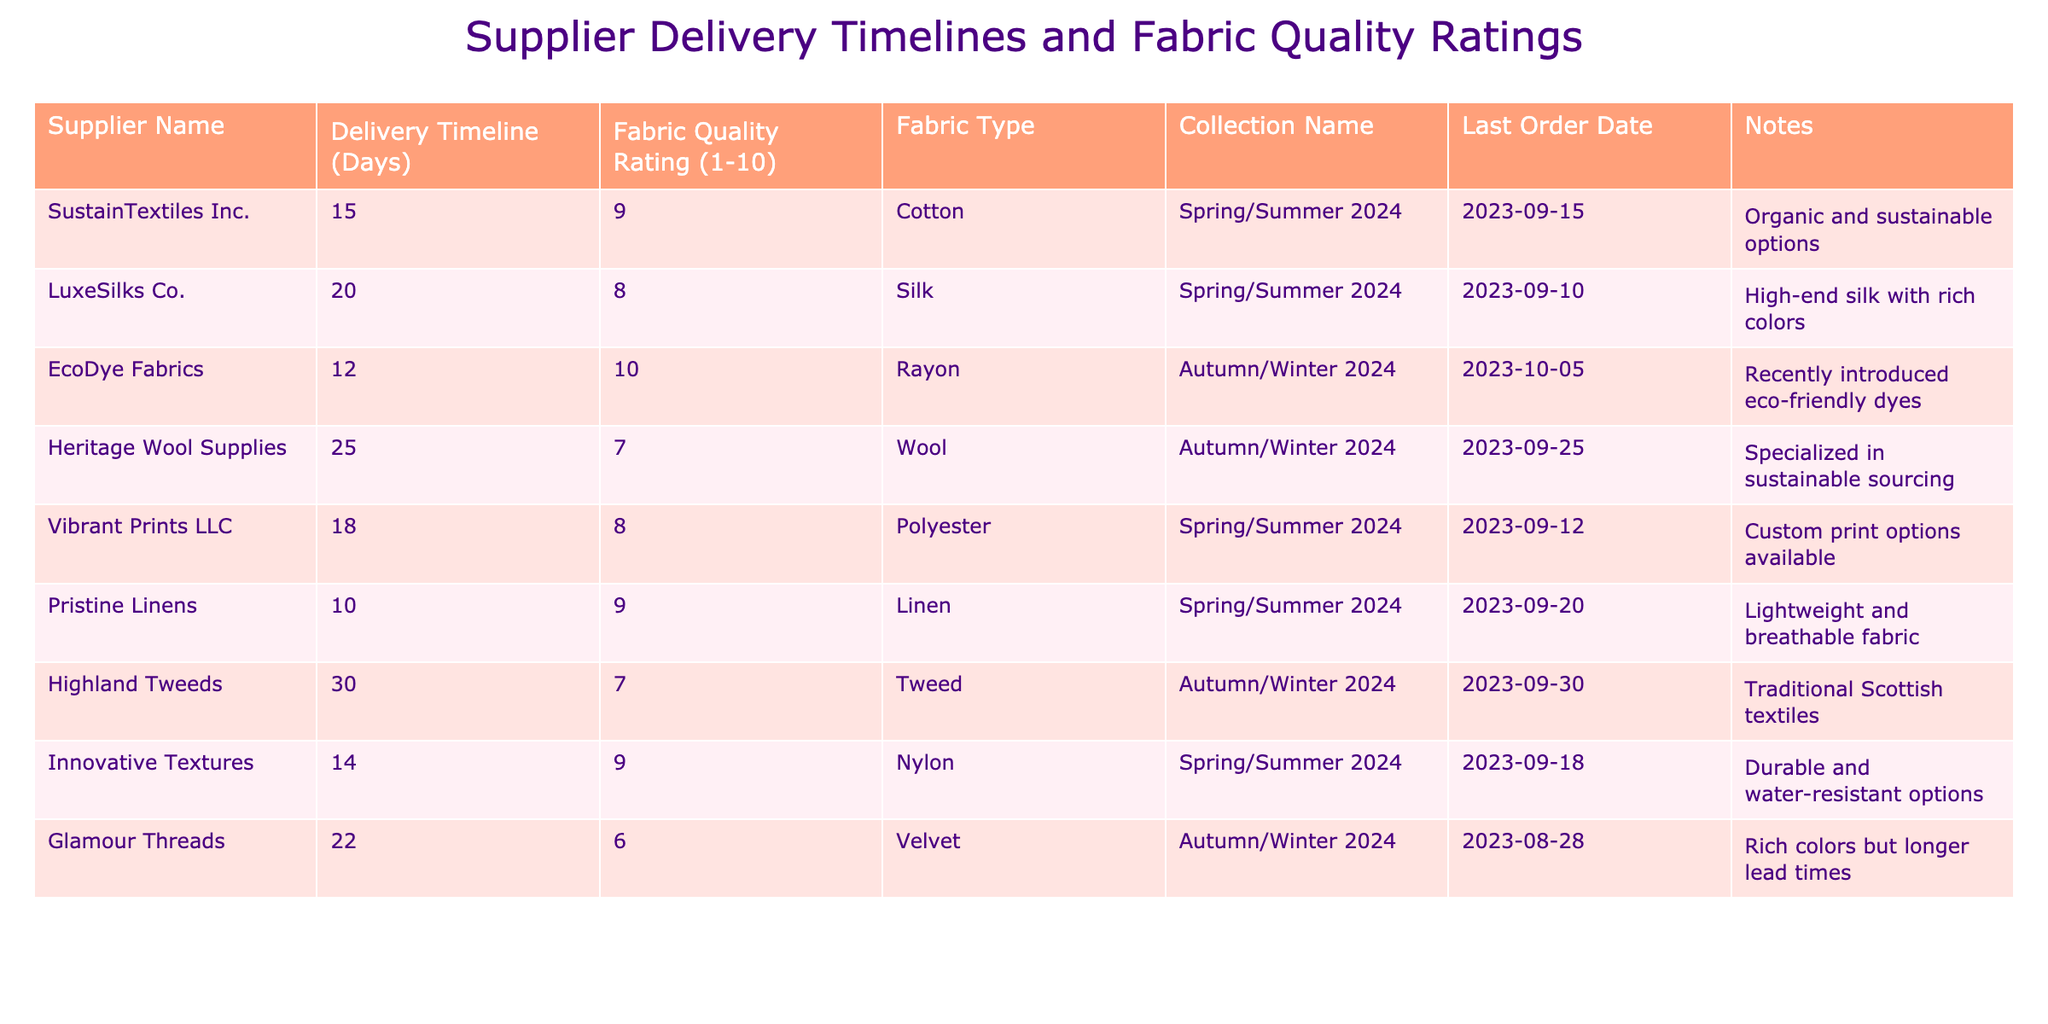What is the delivery timeline for SustainTextiles Inc.? Referring to the table, the delivery timeline listed for SustainTextiles Inc. is 15 days.
Answer: 15 days Which fabric type has the highest quality rating? The table shows that the fabric type with the highest quality rating of 10 is Rayon from EcoDye Fabrics.
Answer: Rayon What is the average delivery timeline for fabric suppliers offering collections in Spring/Summer 2024? The relevant suppliers for Spring/Summer 2024 are SustainTextiles Inc. (15), LuxeSilks Co. (20), Vibrant Prints LLC (18), Pristine Linens (10), and Innovative Textures (14). Adding these gives 15 + 20 + 18 + 10 + 14 = 77 days. There are 5 suppliers, so the average is 77/5 = 15.4 days.
Answer: 15.4 days Is the fabric quality rating for Glamour Threads higher than 5? According to the table, Glamour Threads has a fabric quality rating of 6, which is indeed higher than 5.
Answer: Yes Which fabric supplier has the longest delivery timeline and what is that timeline? The longest delivery timeline in the table is for Highland Tweeds, which is 30 days.
Answer: 30 days What is the total fabric quality rating for all suppliers in the Autumn/Winter 2024 collection? The suppliers for Autumn/Winter 2024 are EcoDye Fabrics (10), Heritage Wool Supplies (7), Highland Tweeds (7), and Glamour Threads (6). Adding these gives 10 + 7 + 7 + 6 = 30.
Answer: 30 Do any of the suppliers have a delivery timeline of less than 15 days? Looking at the table, Pristine Linens has a delivery timeline of 10 days, which is less than 15 days.
Answer: Yes What is the difference in fabric quality ratings between the highest-rated fabric and the lowest-rated fabric? The highest fabric quality rating is 10 (Rayon) and the lowest is 6 (Velvet). The difference is 10 - 6 = 4.
Answer: 4 Which supplier has the most recent last order date? Checking the last order dates, Glamour Threads has the earliest last order date on 2023-08-28 compared to others, making it the most recent in terms of orders.
Answer: Glamour Threads If you prioritize fabric quality ratings, which supplier would you select for the Spring/Summer 2024 collection? The highest quality ratings for Spring/Summer 2024 are from SustainTextiles Inc. and Pristine Linens (both rated 9). Therefore, either of these suppliers would be a good choice.
Answer: SustainTextiles Inc. or Pristine Linens 